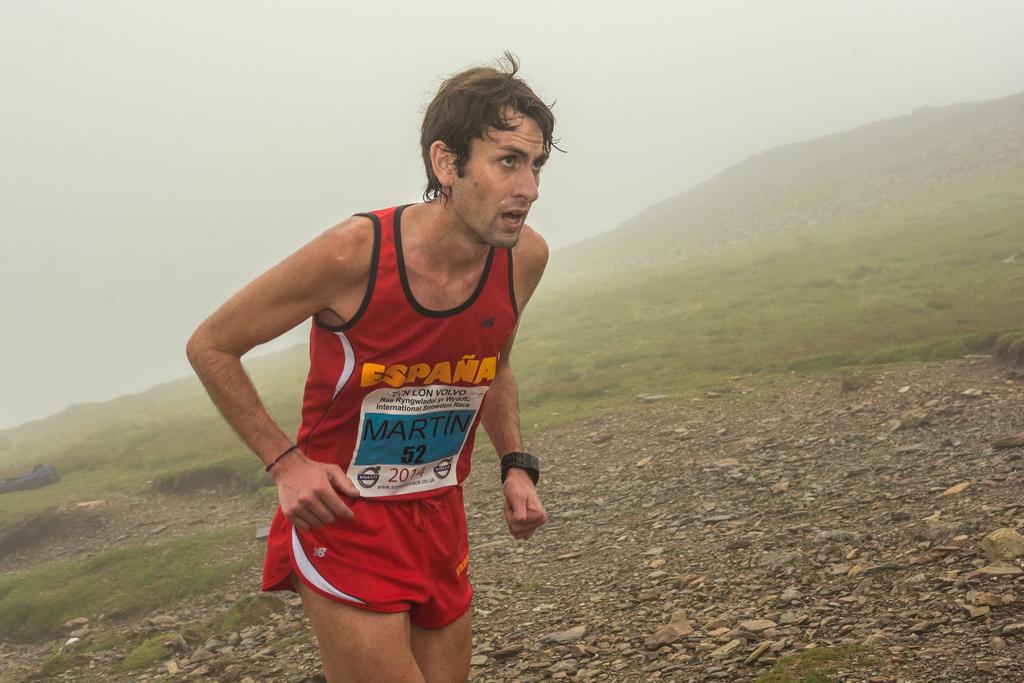<image>
Provide a brief description of the given image. A RUNNER ON A GRAVEL HILL WEARING RED TANK TOP AND SHORTS NAMED MARTIN 